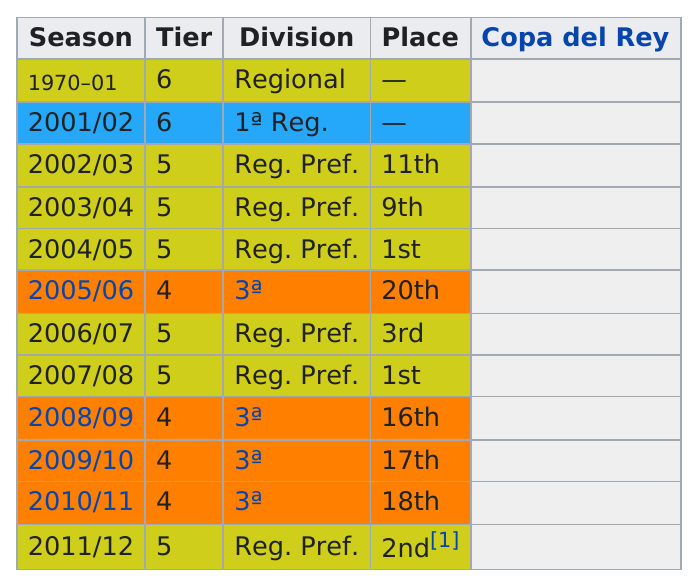Identify some key points in this picture. Before the 2007-2008 season, the team's finishing place was third. There are 12 seasons in total. The team finished 16th in the 2008/09 season, having finished first in the previous season. There is no evidence that Manchester United placed lower than 18th in the 2005/06 season. The total number of divisions on the chart is four. 